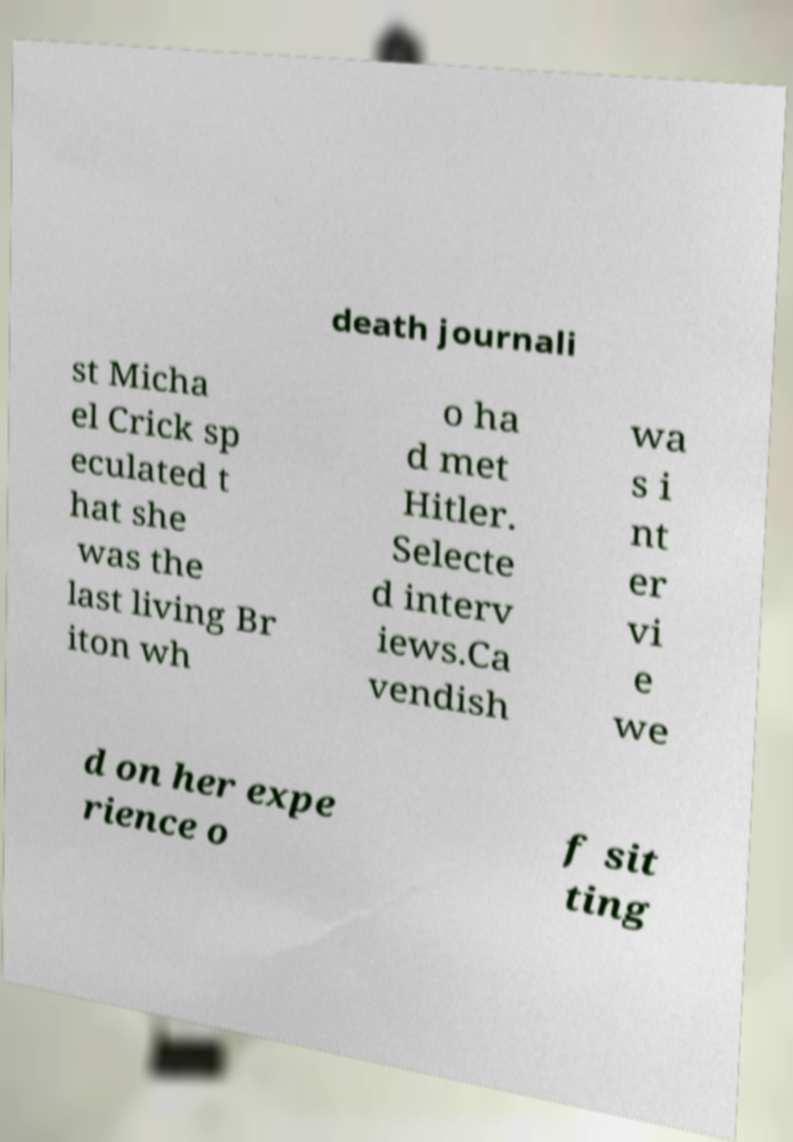Could you assist in decoding the text presented in this image and type it out clearly? death journali st Micha el Crick sp eculated t hat she was the last living Br iton wh o ha d met Hitler. Selecte d interv iews.Ca vendish wa s i nt er vi e we d on her expe rience o f sit ting 